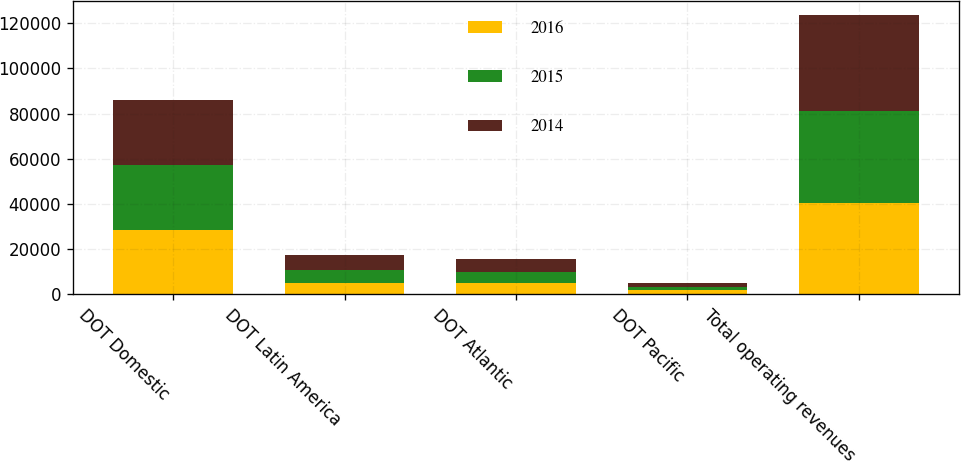Convert chart to OTSL. <chart><loc_0><loc_0><loc_500><loc_500><stacked_bar_chart><ecel><fcel>DOT Domestic<fcel>DOT Latin America<fcel>DOT Atlantic<fcel>DOT Pacific<fcel>Total operating revenues<nl><fcel>2016<fcel>28620<fcel>4995<fcel>4769<fcel>1796<fcel>40180<nl><fcel>2015<fcel>28761<fcel>5539<fcel>5146<fcel>1544<fcel>40990<nl><fcel>2014<fcel>28568<fcel>6964<fcel>5652<fcel>1466<fcel>42650<nl></chart> 